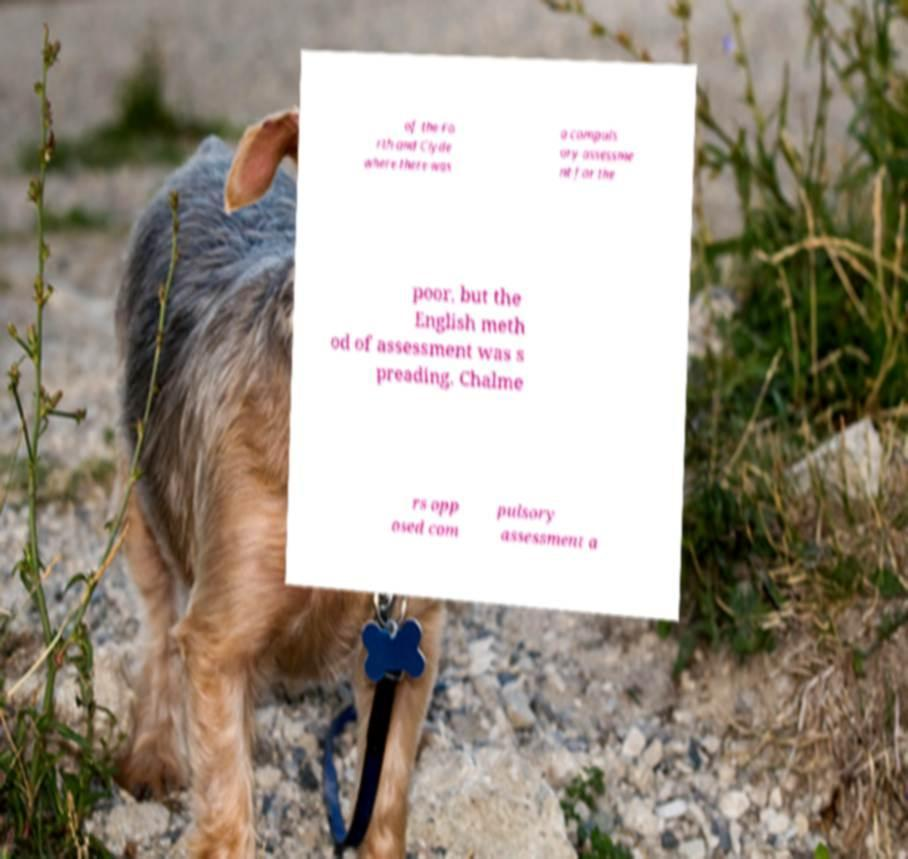Please identify and transcribe the text found in this image. of the Fo rth and Clyde where there was a compuls ory assessme nt for the poor, but the English meth od of assessment was s preading. Chalme rs opp osed com pulsory assessment a 